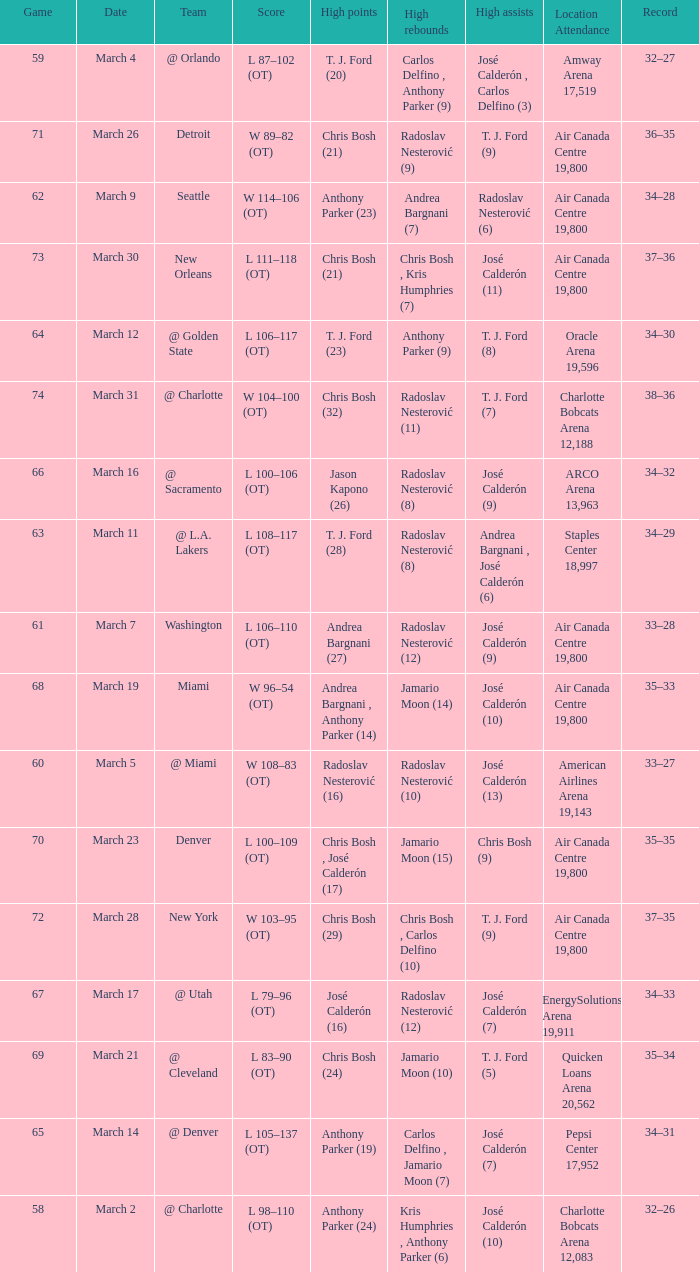How many attended the game on march 16 after over 64 games? ARCO Arena 13,963. 